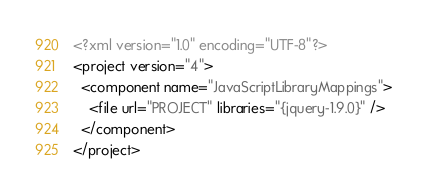<code> <loc_0><loc_0><loc_500><loc_500><_XML_><?xml version="1.0" encoding="UTF-8"?>
<project version="4">
  <component name="JavaScriptLibraryMappings">
    <file url="PROJECT" libraries="{jquery-1.9.0}" />
  </component>
</project></code> 